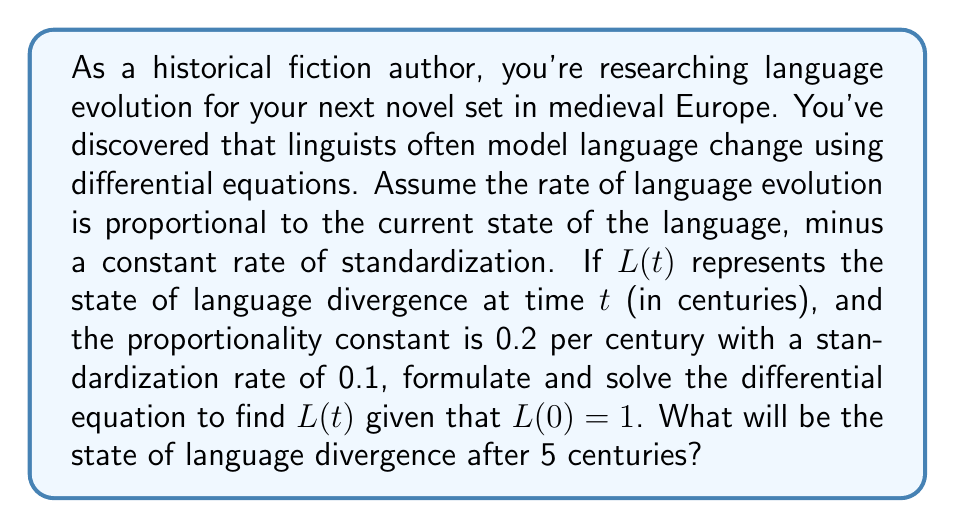Show me your answer to this math problem. Let's approach this step-by-step:

1) First, we formulate the differential equation based on the given information:

   $$\frac{dL}{dt} = 0.2L - 0.1$$

   This equation states that the rate of change of language divergence is proportional to the current state minus a constant.

2) This is a linear first-order differential equation of the form:

   $$\frac{dy}{dx} + P(x)y = Q(x)$$

   Where in our case, $P(x) = -0.2$ and $Q(x) = 0.1$

3) The general solution for this type of equation is:

   $$y = e^{-\int P(x)dx} (\int Q(x)e^{\int P(x)dx}dx + C)$$

4) Solving our equation:

   $$L = e^{0.2t} (\int 0.1e^{-0.2t}dt + C)$$

5) Integrating:

   $$L = e^{0.2t} (-0.5e^{-0.2t} + C)$$

6) Simplifying:

   $$L = -0.5 + Ce^{0.2t}$$

7) Using the initial condition $L(0) = 1$:

   $$1 = -0.5 + C$$
   $$C = 1.5$$

8) Therefore, the particular solution is:

   $$L(t) = -0.5 + 1.5e^{0.2t}$$

9) To find the state of language divergence after 5 centuries, we substitute $t = 5$:

   $$L(5) = -0.5 + 1.5e^{0.2(5)} = -0.5 + 1.5e^{1} \approx 3.58$$
Answer: The state of language divergence after 5 centuries will be approximately 3.58. 